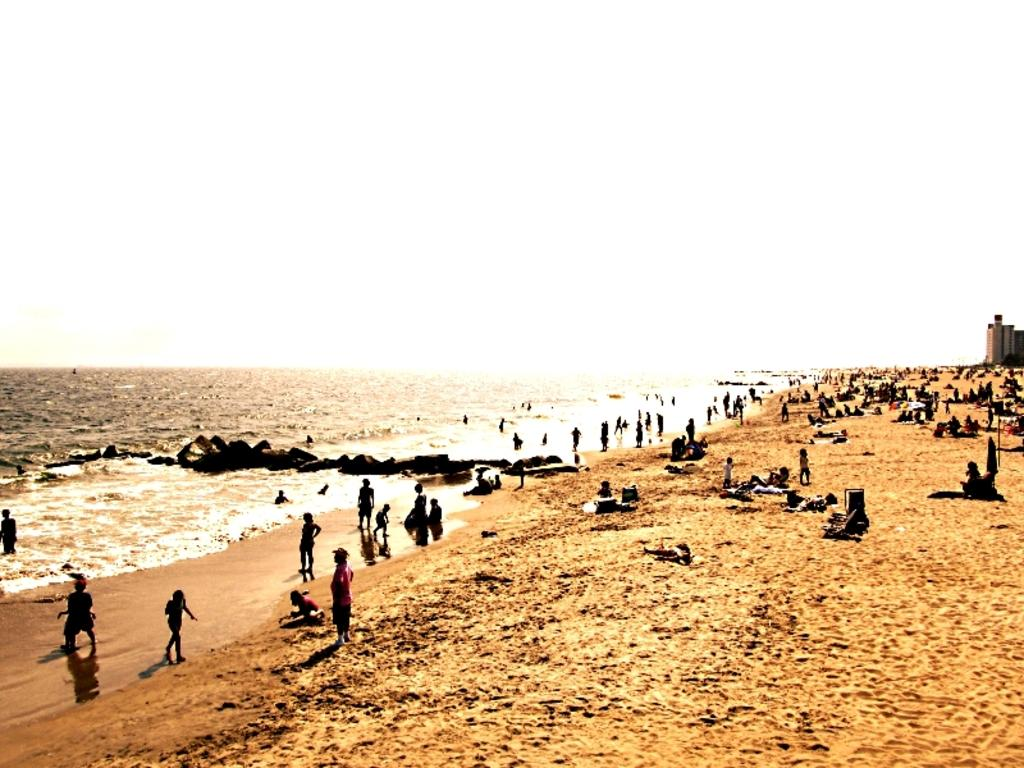How many people are in the image? There is a group of people in the image, but the exact number is not specified. What are the people in the image doing? Some people are standing, while others are sitting. What can be seen in the background of the image? There are buildings and water visible in the background of the image. What is the color of the sky in the image? The sky is white in color. What type of song is being sung by the people in the image? There is no indication in the image that the people are singing a song, so it cannot be determined from the picture. 